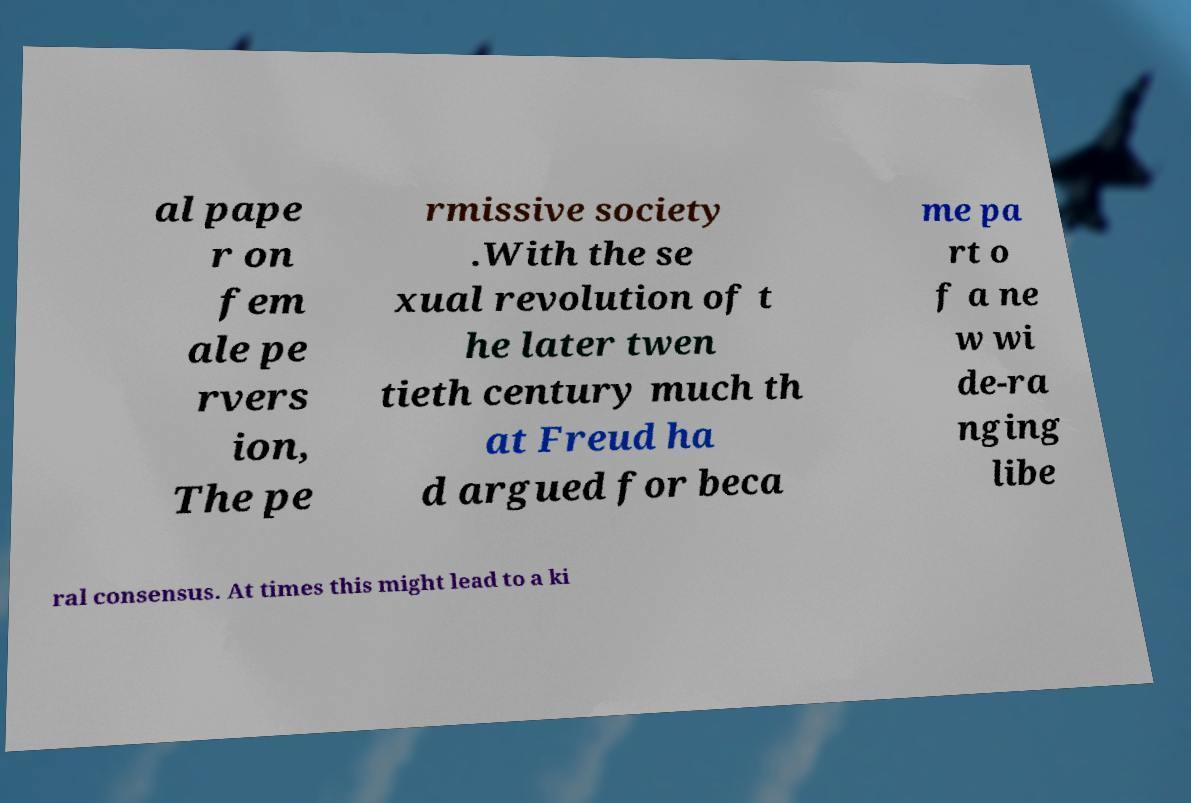There's text embedded in this image that I need extracted. Can you transcribe it verbatim? al pape r on fem ale pe rvers ion, The pe rmissive society .With the se xual revolution of t he later twen tieth century much th at Freud ha d argued for beca me pa rt o f a ne w wi de-ra nging libe ral consensus. At times this might lead to a ki 